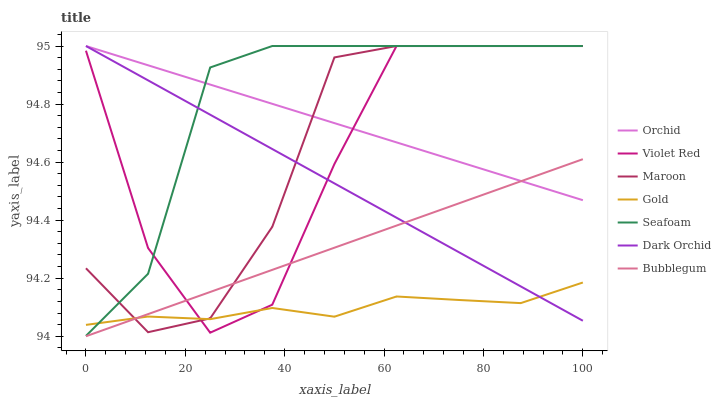Does Bubblegum have the minimum area under the curve?
Answer yes or no. No. Does Bubblegum have the maximum area under the curve?
Answer yes or no. No. Is Gold the smoothest?
Answer yes or no. No. Is Gold the roughest?
Answer yes or no. No. Does Gold have the lowest value?
Answer yes or no. No. Does Bubblegum have the highest value?
Answer yes or no. No. Is Gold less than Orchid?
Answer yes or no. Yes. Is Seafoam greater than Bubblegum?
Answer yes or no. Yes. Does Gold intersect Orchid?
Answer yes or no. No. 